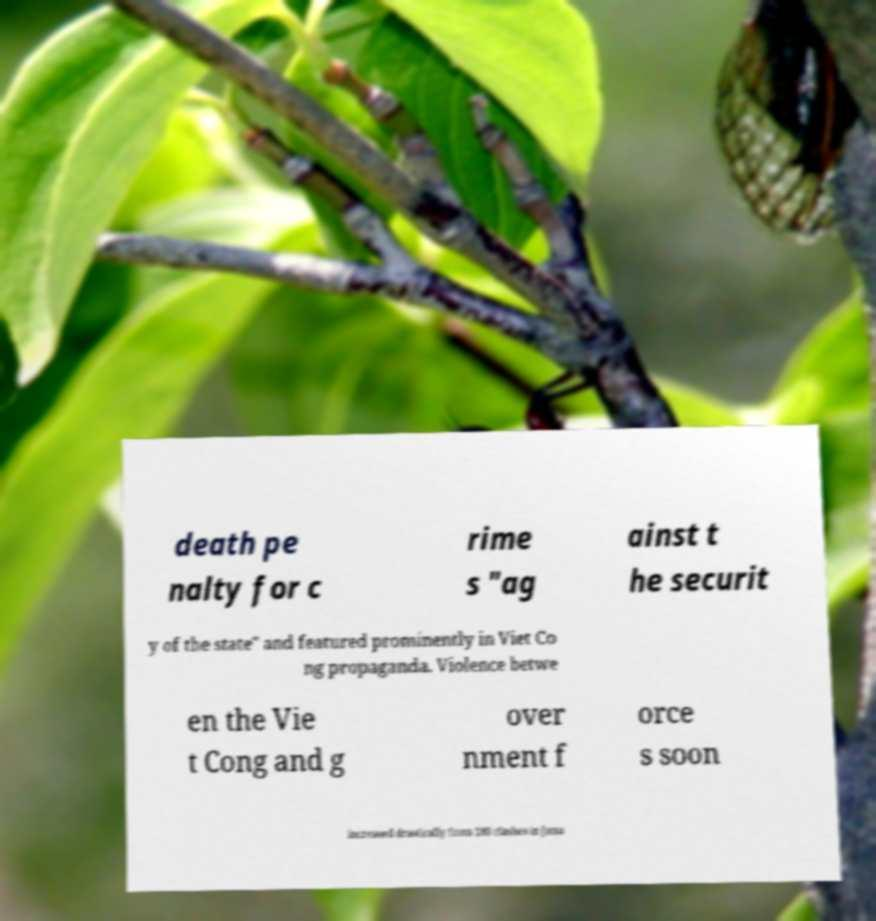Please identify and transcribe the text found in this image. death pe nalty for c rime s "ag ainst t he securit y of the state" and featured prominently in Viet Co ng propaganda. Violence betwe en the Vie t Cong and g over nment f orce s soon increased drastically from 180 clashes in Janu 